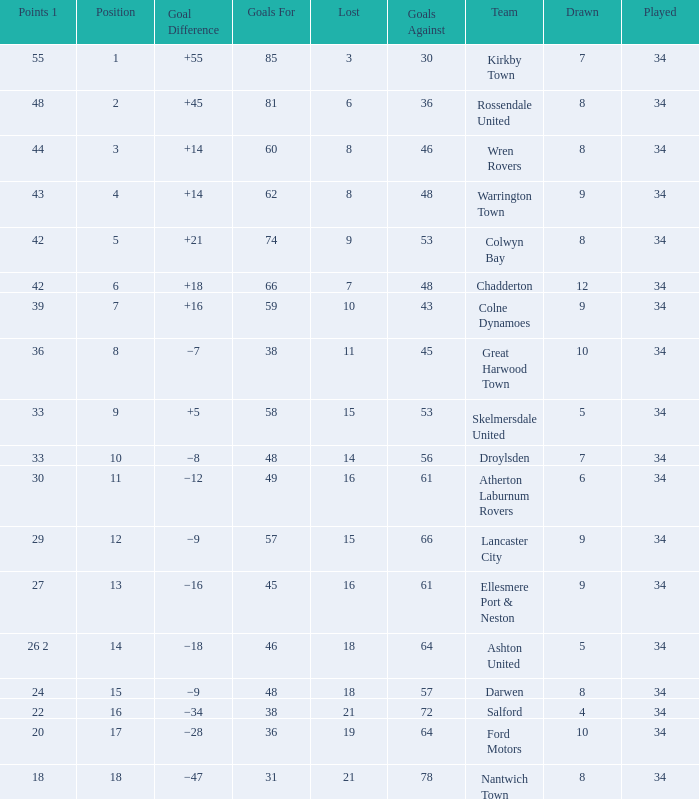What is the total number of positions when there are more than 48 goals against, 1 of 29 points are played, and less than 34 games have been played? 0.0. 